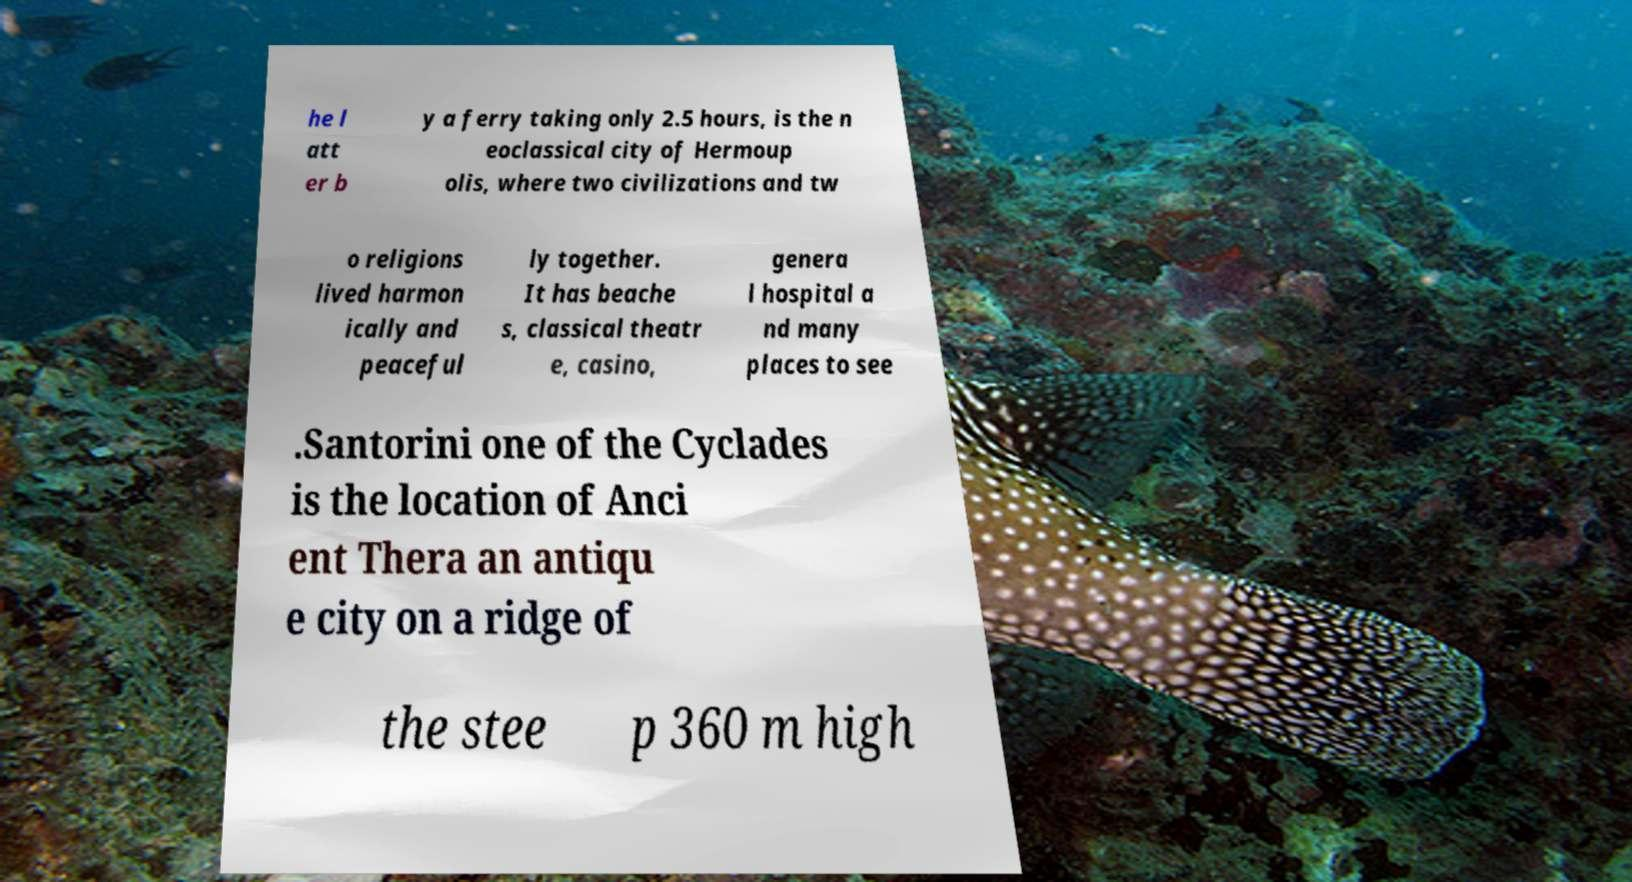Could you extract and type out the text from this image? he l att er b y a ferry taking only 2.5 hours, is the n eoclassical city of Hermoup olis, where two civilizations and tw o religions lived harmon ically and peaceful ly together. It has beache s, classical theatr e, casino, genera l hospital a nd many places to see .Santorini one of the Cyclades is the location of Anci ent Thera an antiqu e city on a ridge of the stee p 360 m high 